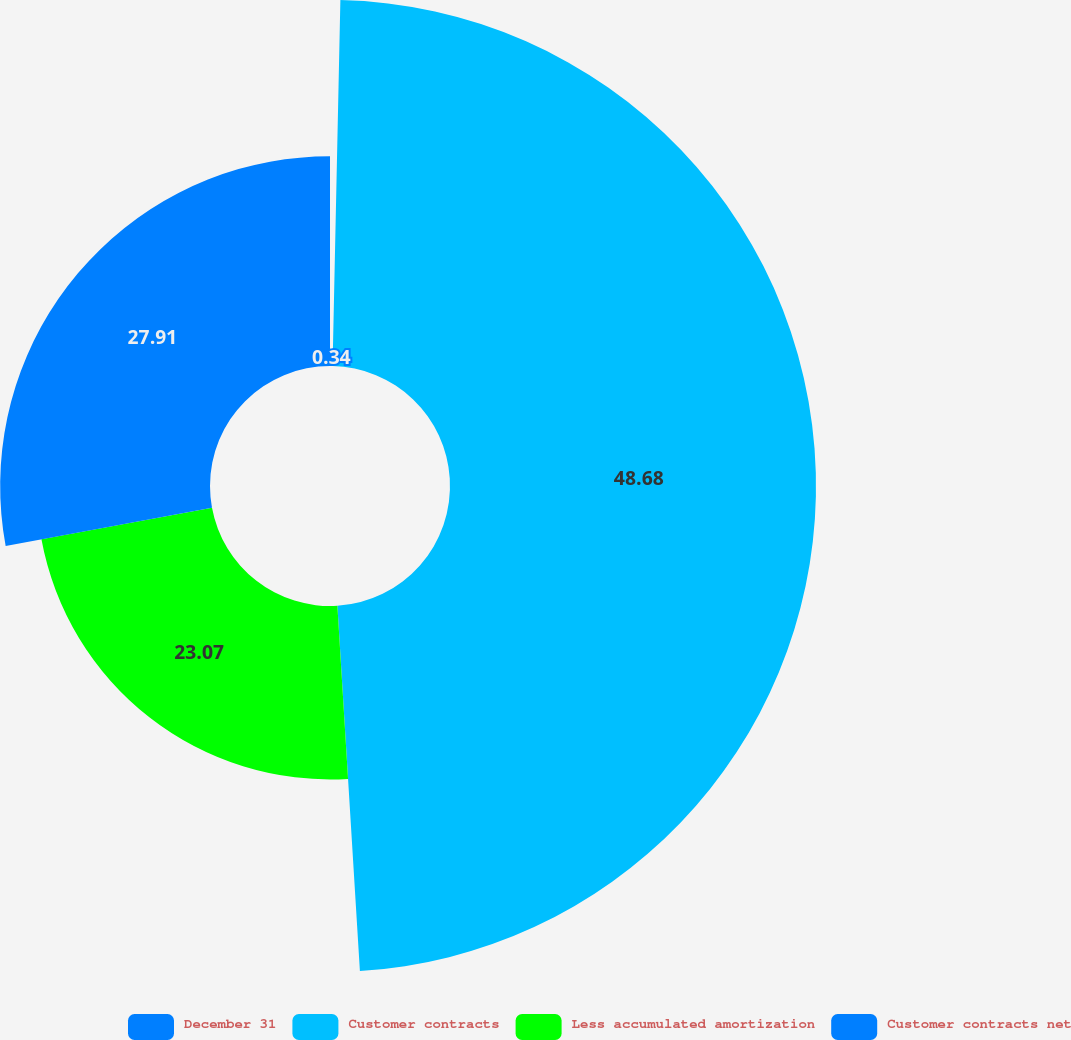Convert chart to OTSL. <chart><loc_0><loc_0><loc_500><loc_500><pie_chart><fcel>December 31<fcel>Customer contracts<fcel>Less accumulated amortization<fcel>Customer contracts net<nl><fcel>0.34%<fcel>48.68%<fcel>23.07%<fcel>27.91%<nl></chart> 